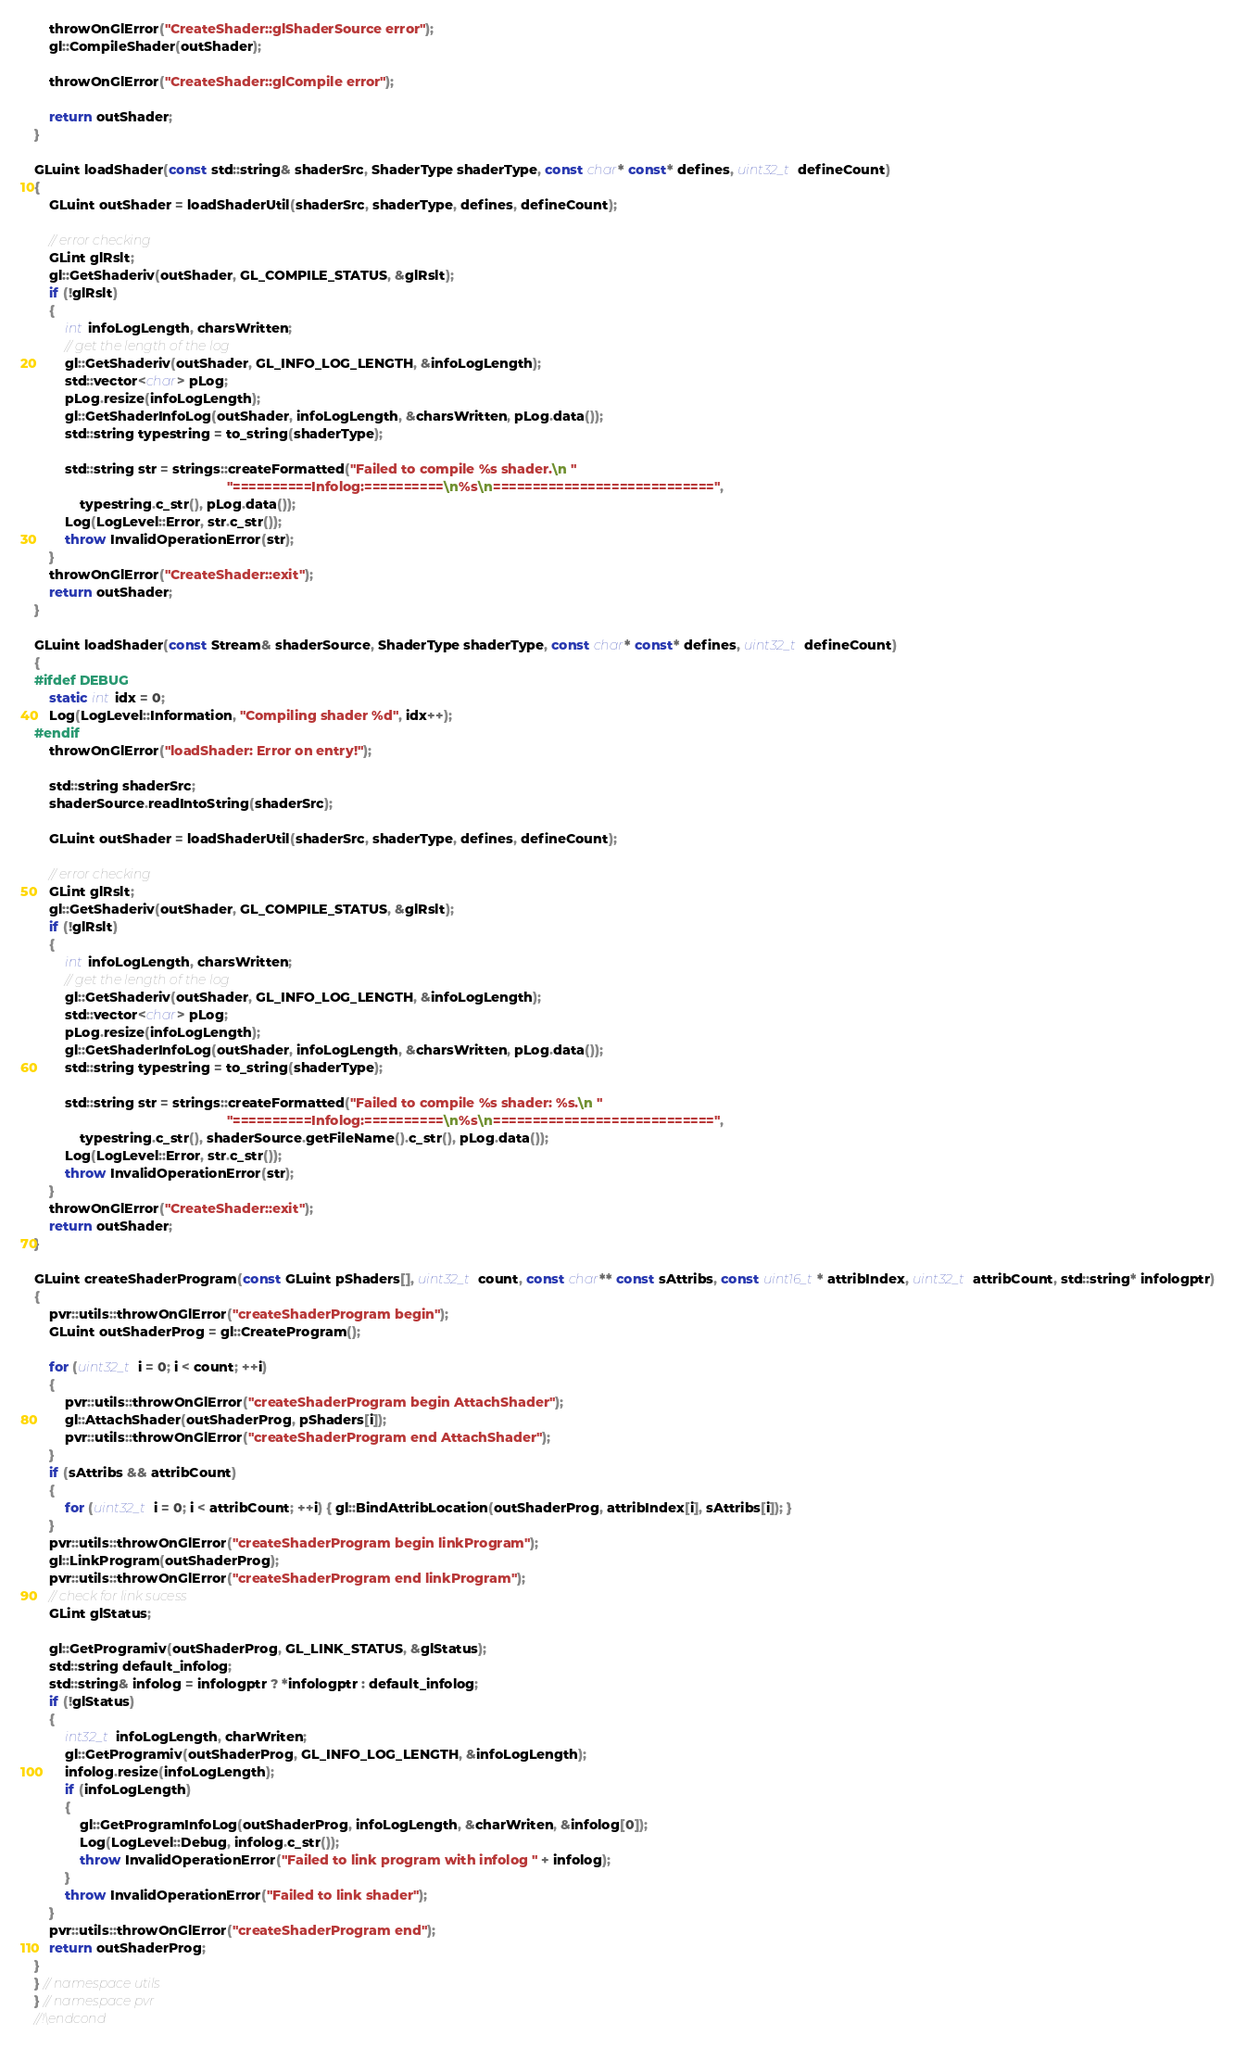<code> <loc_0><loc_0><loc_500><loc_500><_C++_>	throwOnGlError("CreateShader::glShaderSource error");
	gl::CompileShader(outShader);

	throwOnGlError("CreateShader::glCompile error");

	return outShader;
}

GLuint loadShader(const std::string& shaderSrc, ShaderType shaderType, const char* const* defines, uint32_t defineCount)
{
	GLuint outShader = loadShaderUtil(shaderSrc, shaderType, defines, defineCount);

	// error checking
	GLint glRslt;
	gl::GetShaderiv(outShader, GL_COMPILE_STATUS, &glRslt);
	if (!glRslt)
	{
		int infoLogLength, charsWritten;
		// get the length of the log
		gl::GetShaderiv(outShader, GL_INFO_LOG_LENGTH, &infoLogLength);
		std::vector<char> pLog;
		pLog.resize(infoLogLength);
		gl::GetShaderInfoLog(outShader, infoLogLength, &charsWritten, pLog.data());
		std::string typestring = to_string(shaderType);

		std::string str = strings::createFormatted("Failed to compile %s shader.\n "
												   "==========Infolog:==========\n%s\n============================",
			typestring.c_str(), pLog.data());
		Log(LogLevel::Error, str.c_str());
		throw InvalidOperationError(str);
	}
	throwOnGlError("CreateShader::exit");
	return outShader;
}

GLuint loadShader(const Stream& shaderSource, ShaderType shaderType, const char* const* defines, uint32_t defineCount)
{
#ifdef DEBUG
	static int idx = 0;
	Log(LogLevel::Information, "Compiling shader %d", idx++);
#endif
	throwOnGlError("loadShader: Error on entry!");

	std::string shaderSrc;
	shaderSource.readIntoString(shaderSrc);

	GLuint outShader = loadShaderUtil(shaderSrc, shaderType, defines, defineCount);

	// error checking
	GLint glRslt;
	gl::GetShaderiv(outShader, GL_COMPILE_STATUS, &glRslt);
	if (!glRslt)
	{
		int infoLogLength, charsWritten;
		// get the length of the log
		gl::GetShaderiv(outShader, GL_INFO_LOG_LENGTH, &infoLogLength);
		std::vector<char> pLog;
		pLog.resize(infoLogLength);
		gl::GetShaderInfoLog(outShader, infoLogLength, &charsWritten, pLog.data());
		std::string typestring = to_string(shaderType);

		std::string str = strings::createFormatted("Failed to compile %s shader: %s.\n "
												   "==========Infolog:==========\n%s\n============================",
			typestring.c_str(), shaderSource.getFileName().c_str(), pLog.data());
		Log(LogLevel::Error, str.c_str());
		throw InvalidOperationError(str);
	}
	throwOnGlError("CreateShader::exit");
	return outShader;
}

GLuint createShaderProgram(const GLuint pShaders[], uint32_t count, const char** const sAttribs, const uint16_t* attribIndex, uint32_t attribCount, std::string* infologptr)
{
	pvr::utils::throwOnGlError("createShaderProgram begin");
	GLuint outShaderProg = gl::CreateProgram();

	for (uint32_t i = 0; i < count; ++i)
	{
		pvr::utils::throwOnGlError("createShaderProgram begin AttachShader");
		gl::AttachShader(outShaderProg, pShaders[i]);
		pvr::utils::throwOnGlError("createShaderProgram end AttachShader");
	}
	if (sAttribs && attribCount)
	{
		for (uint32_t i = 0; i < attribCount; ++i) { gl::BindAttribLocation(outShaderProg, attribIndex[i], sAttribs[i]); }
	}
	pvr::utils::throwOnGlError("createShaderProgram begin linkProgram");
	gl::LinkProgram(outShaderProg);
	pvr::utils::throwOnGlError("createShaderProgram end linkProgram");
	// check for link sucess
	GLint glStatus;

	gl::GetProgramiv(outShaderProg, GL_LINK_STATUS, &glStatus);
	std::string default_infolog;
	std::string& infolog = infologptr ? *infologptr : default_infolog;
	if (!glStatus)
	{
		int32_t infoLogLength, charWriten;
		gl::GetProgramiv(outShaderProg, GL_INFO_LOG_LENGTH, &infoLogLength);
		infolog.resize(infoLogLength);
		if (infoLogLength)
		{
			gl::GetProgramInfoLog(outShaderProg, infoLogLength, &charWriten, &infolog[0]);
			Log(LogLevel::Debug, infolog.c_str());
			throw InvalidOperationError("Failed to link program with infolog " + infolog);
		}
		throw InvalidOperationError("Failed to link shader");
	}
	pvr::utils::throwOnGlError("createShaderProgram end");
	return outShaderProg;
}
} // namespace utils
} // namespace pvr
//!\endcond
</code> 